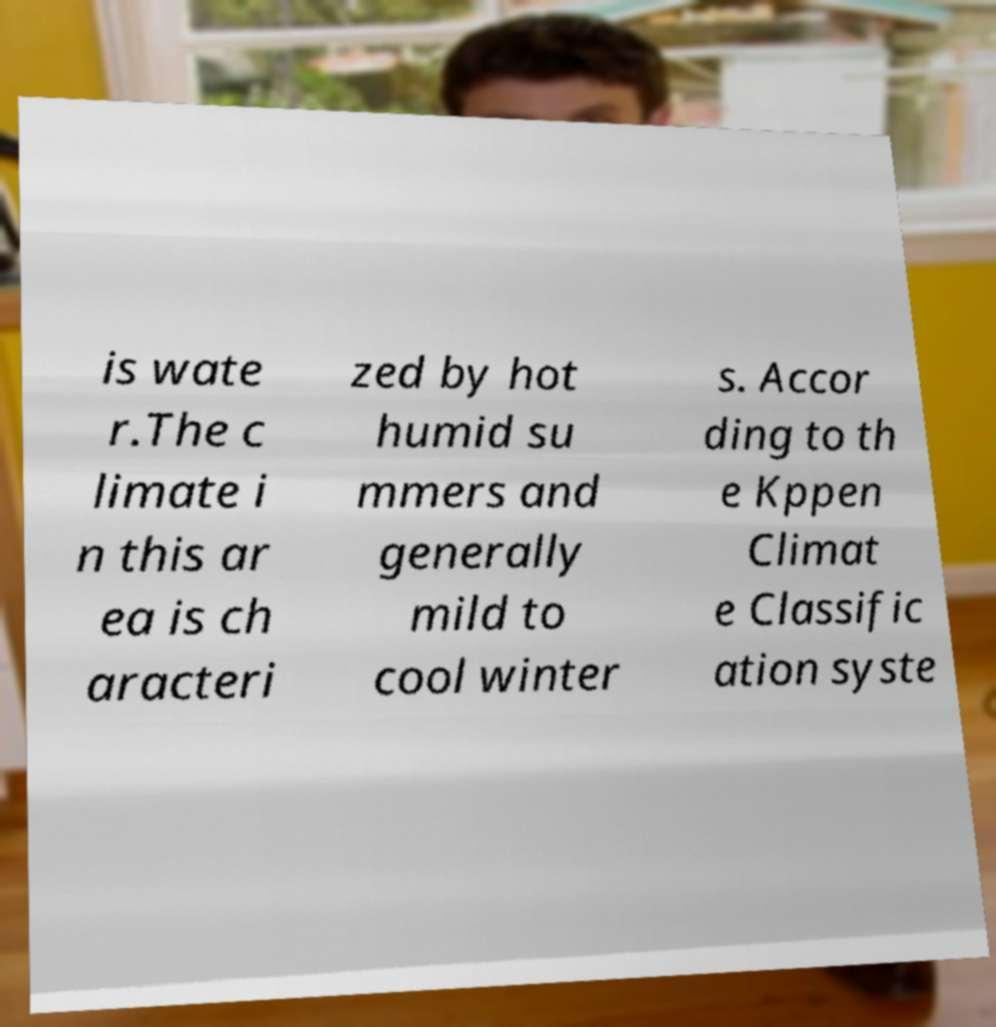Could you extract and type out the text from this image? is wate r.The c limate i n this ar ea is ch aracteri zed by hot humid su mmers and generally mild to cool winter s. Accor ding to th e Kppen Climat e Classific ation syste 